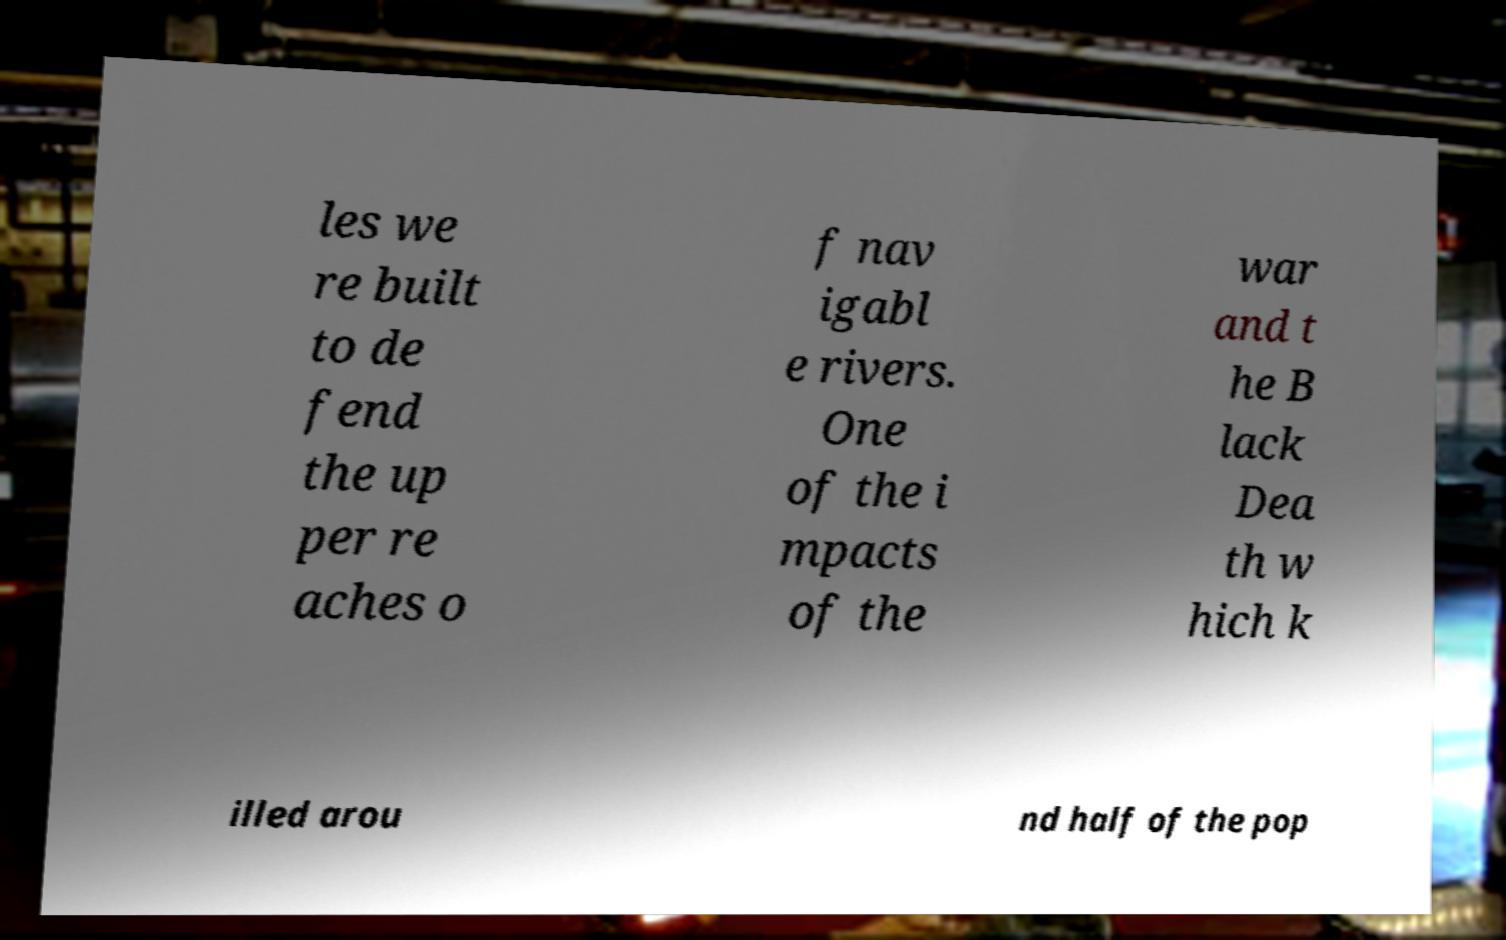Can you accurately transcribe the text from the provided image for me? les we re built to de fend the up per re aches o f nav igabl e rivers. One of the i mpacts of the war and t he B lack Dea th w hich k illed arou nd half of the pop 